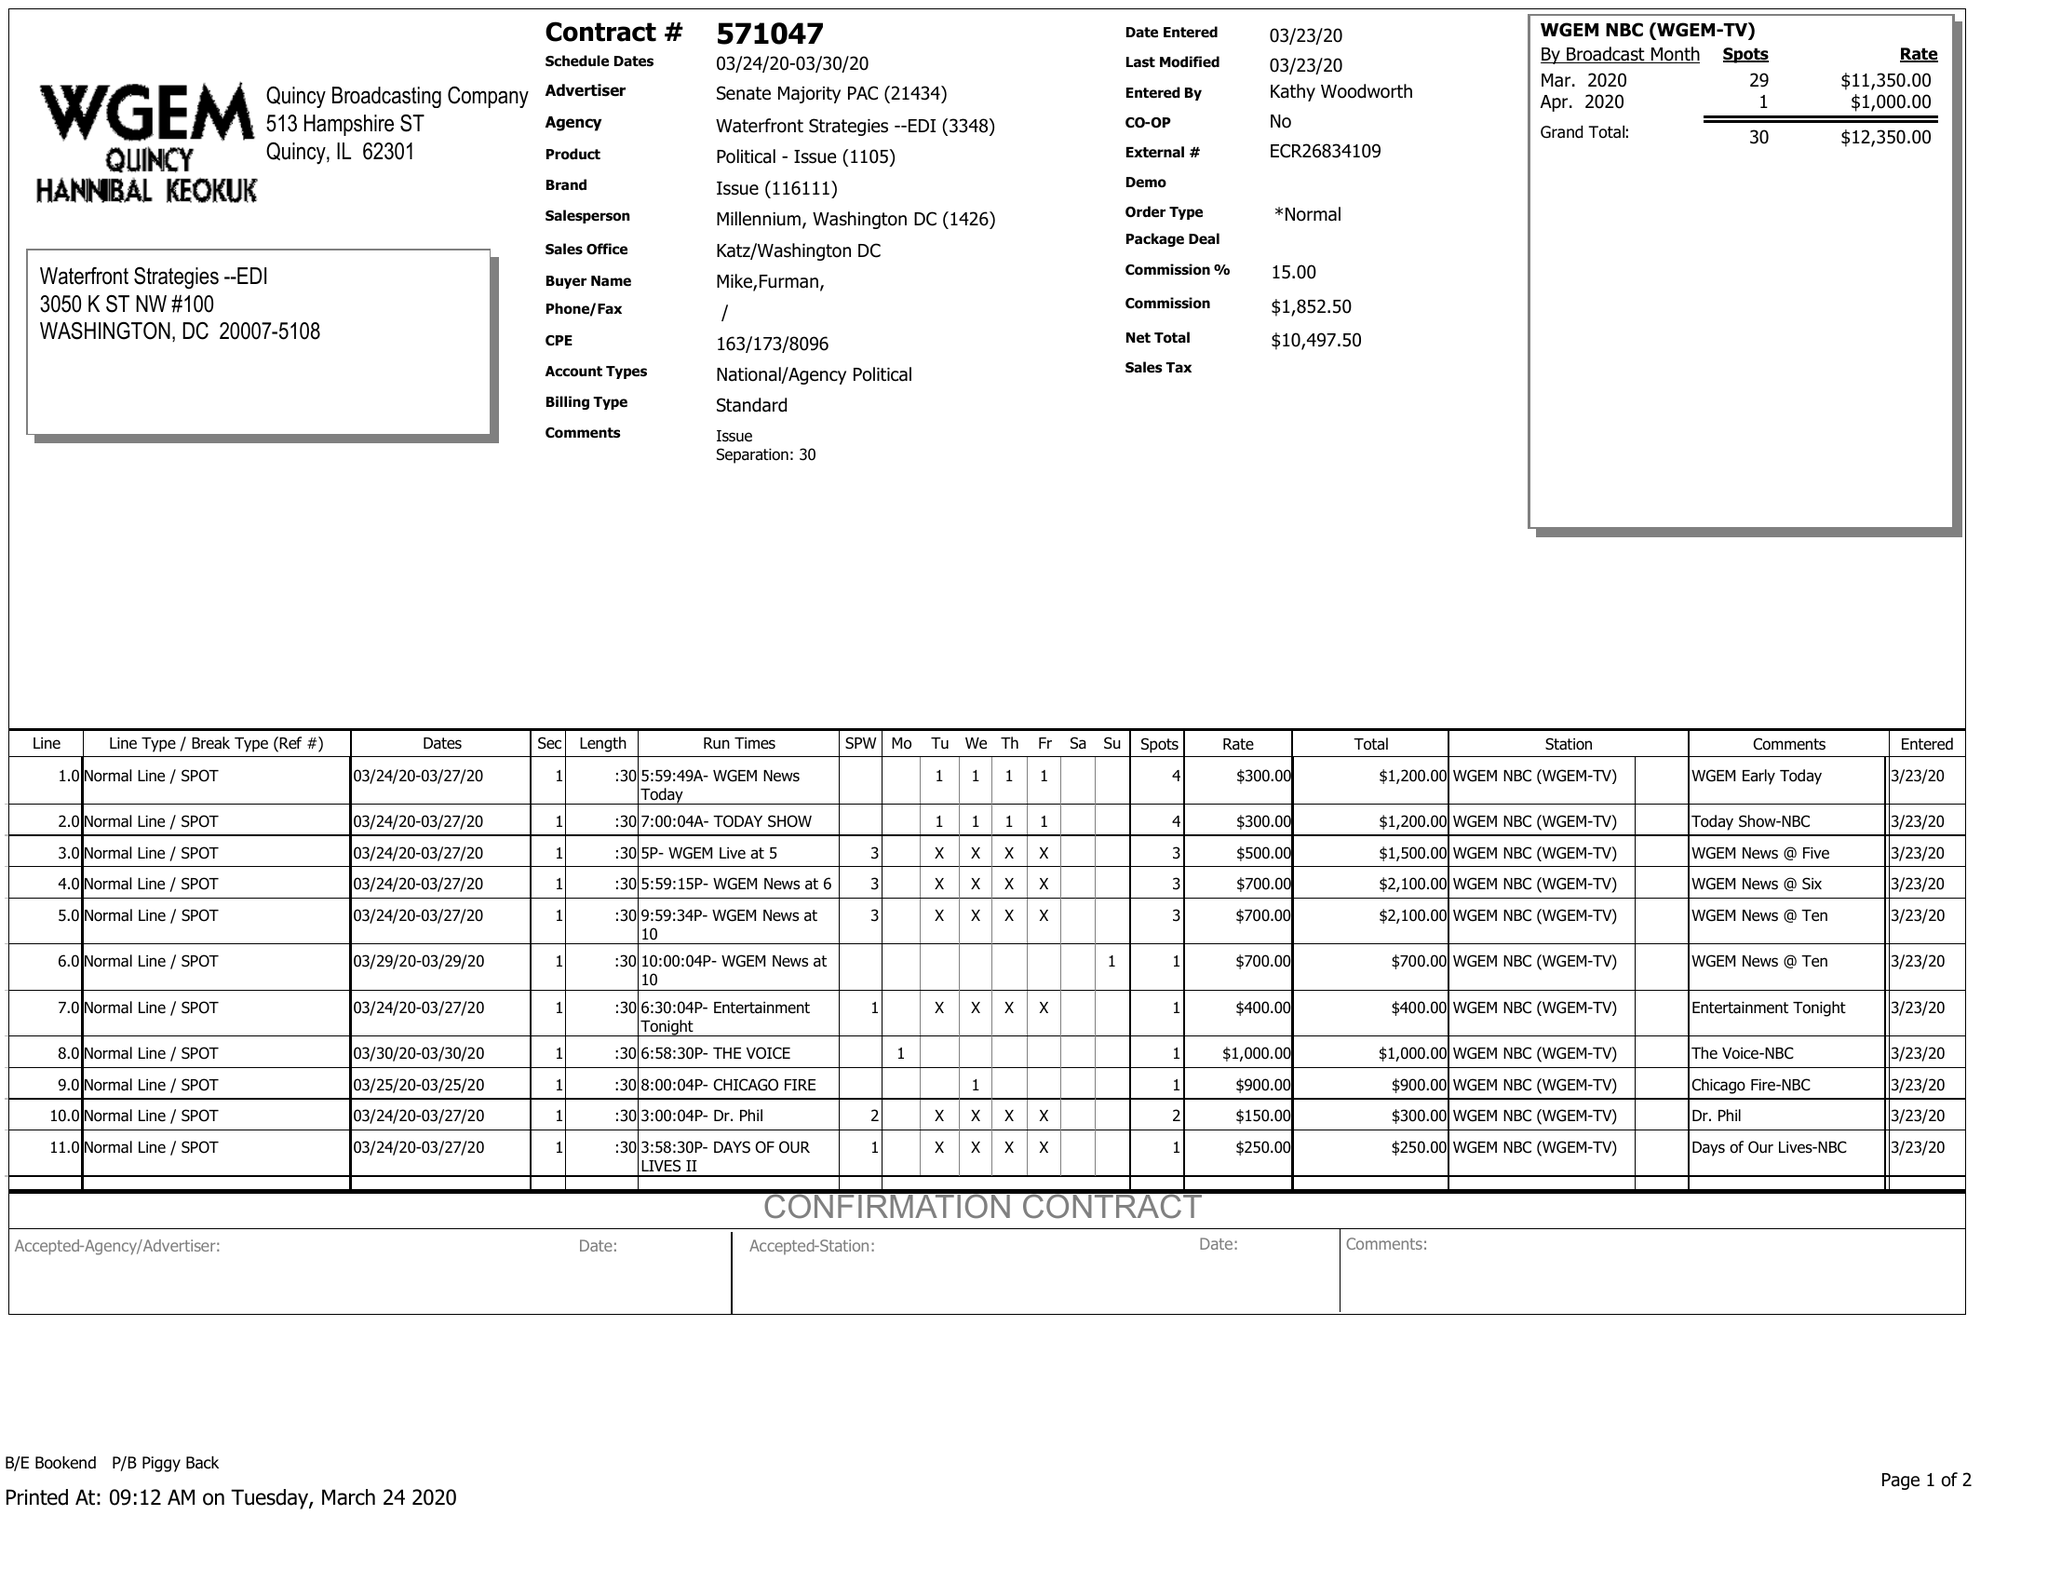What is the value for the contract_num?
Answer the question using a single word or phrase. 571047 